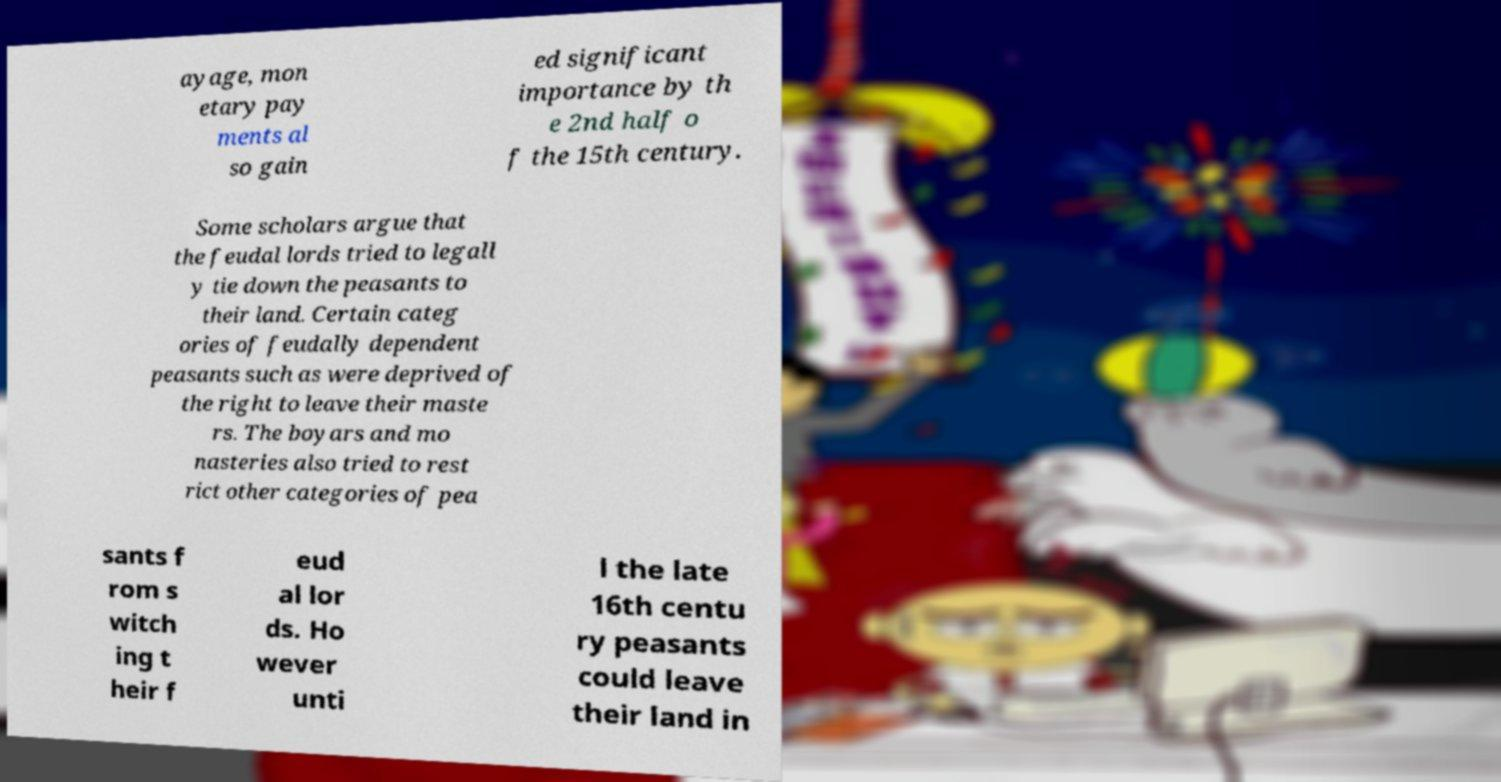Please read and relay the text visible in this image. What does it say? ayage, mon etary pay ments al so gain ed significant importance by th e 2nd half o f the 15th century. Some scholars argue that the feudal lords tried to legall y tie down the peasants to their land. Certain categ ories of feudally dependent peasants such as were deprived of the right to leave their maste rs. The boyars and mo nasteries also tried to rest rict other categories of pea sants f rom s witch ing t heir f eud al lor ds. Ho wever unti l the late 16th centu ry peasants could leave their land in 